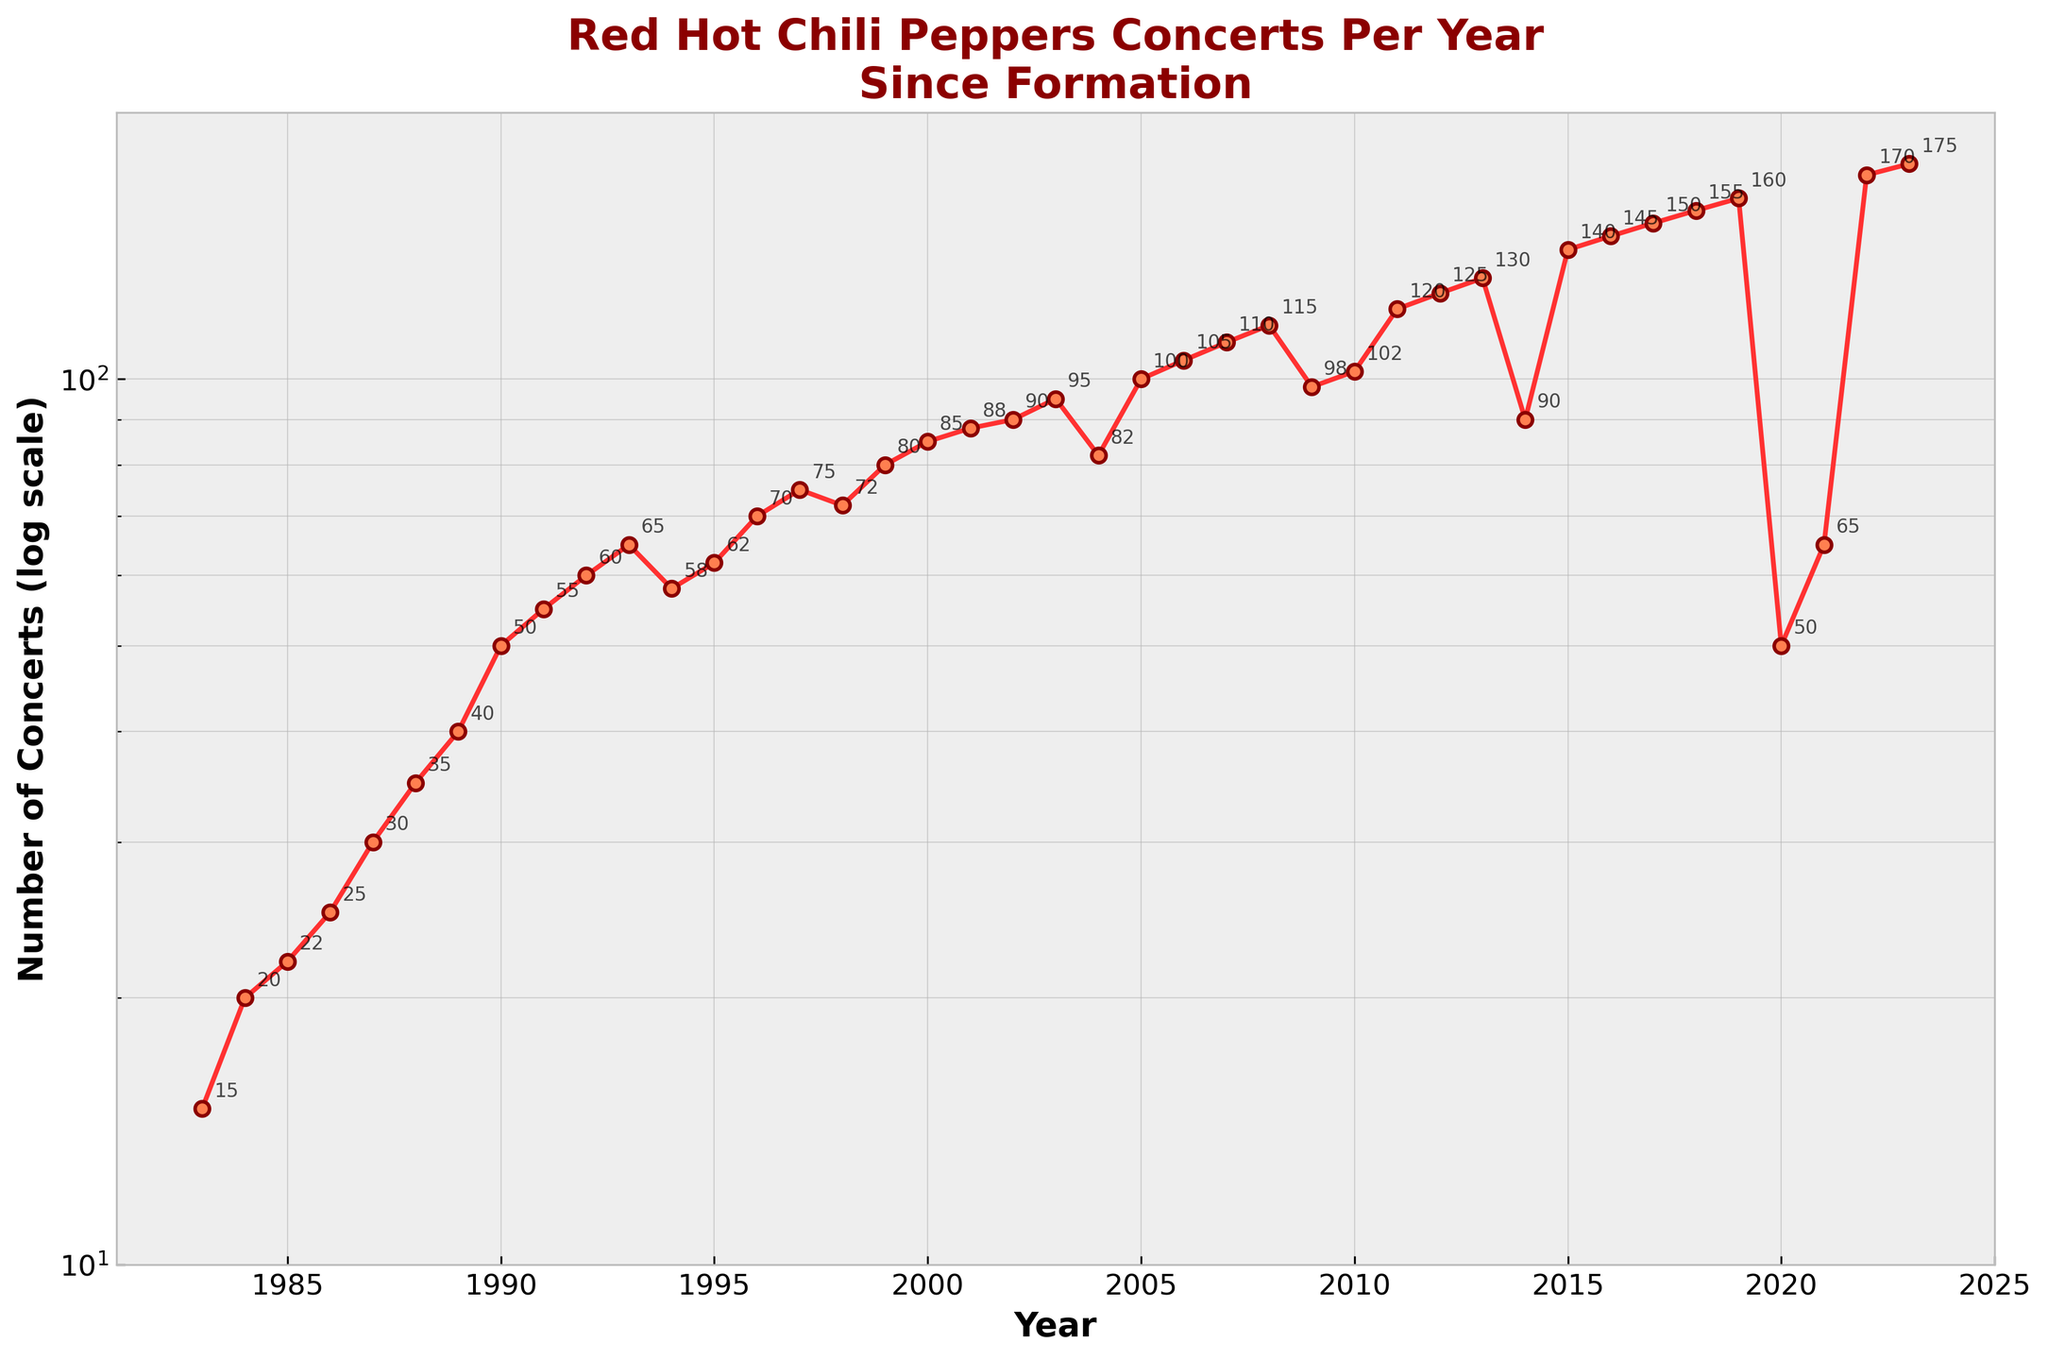How many concerts were held in 2023? The number of concerts in 2023 is annotated next to the data point corresponding to the year 2023.
Answer: 175 What is the title of the plot? The title is prominently displayed at the top of the plot.
Answer: Red Hot Chili Peppers Concerts Per Year Since Formation Which year shows the steepest increase in the number of concerts compared to the previous year? The steepest increase can be identified by looking at the largest vertical jump between consecutive points. The jump from 2021 (65 concerts) to 2022 (170 concerts) is the largest.
Answer: 2022 What is the range of the y-axis? The y-axis range is set by the log scale and the specified limits. It starts from 10 and goes up to 200.
Answer: 10 to 200 In which years did the number of concerts fall compared to the previous year? This is identified by finding where a data point is lower than the previous one. The years are 1994 (lower than 1993), 1998 (lower than 1997), 2004 (lower than 2003), 2009 (lower than 2008), 2014 (lower than 2013), and 2020 (lower than 2019).
Answer: 1994, 1998, 2004, 2009, 2014, 2020 Between 1995 and 2000, what is the average number of concerts held per year? Sum the concert numbers from 1995 to 2000, then divide by the number of years. (62+70+75+72+80+85) / 6 = 74.
Answer: 74 How does the trend from 1983 to 1993 compare to the trend from 2013 to 2023? To compare these trends, look at the general direction and pattern. Both periods show an overall increase in the number of concerts, but the latter period (2013-2023) shows more variability and steeper increases, specifically a notable drop in 2014 and a sharp increase after 2020.
Answer: The latter period has more variability and steeper increases What happened to the number of concerts around the year 2020? In 2020, there is a noticeable drop in the number of concerts, likely due to the global pandemic, but it rebounds sharply in the subsequent years.
Answer: There was a significant drop in 2020 Overall, do the number of concerts seem to increase or decrease since the Red Hot Chili Peppers' formation? By observing the general trend of the plot from 1983 to 2023, there is an overall increase in the number of concerts held annually.
Answer: Increase 